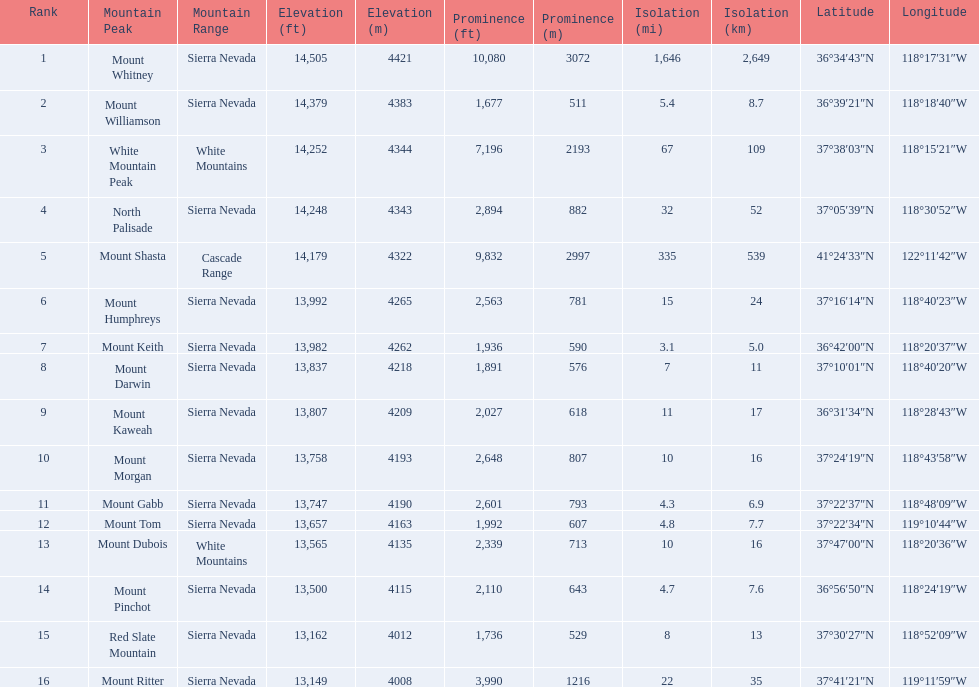What are the peaks in california? Mount Whitney, Mount Williamson, White Mountain Peak, North Palisade, Mount Shasta, Mount Humphreys, Mount Keith, Mount Darwin, Mount Kaweah, Mount Morgan, Mount Gabb, Mount Tom, Mount Dubois, Mount Pinchot, Red Slate Mountain, Mount Ritter. What are the peaks in sierra nevada, california? Mount Whitney, Mount Williamson, North Palisade, Mount Humphreys, Mount Keith, Mount Darwin, Mount Kaweah, Mount Morgan, Mount Gabb, Mount Tom, Mount Pinchot, Red Slate Mountain, Mount Ritter. What are the heights of the peaks in sierra nevada? 14,505 ft\n4421 m, 14,379 ft\n4383 m, 14,248 ft\n4343 m, 13,992 ft\n4265 m, 13,982 ft\n4262 m, 13,837 ft\n4218 m, 13,807 ft\n4209 m, 13,758 ft\n4193 m, 13,747 ft\n4190 m, 13,657 ft\n4163 m, 13,500 ft\n4115 m, 13,162 ft\n4012 m, 13,149 ft\n4008 m. Which is the highest? Mount Whitney. 